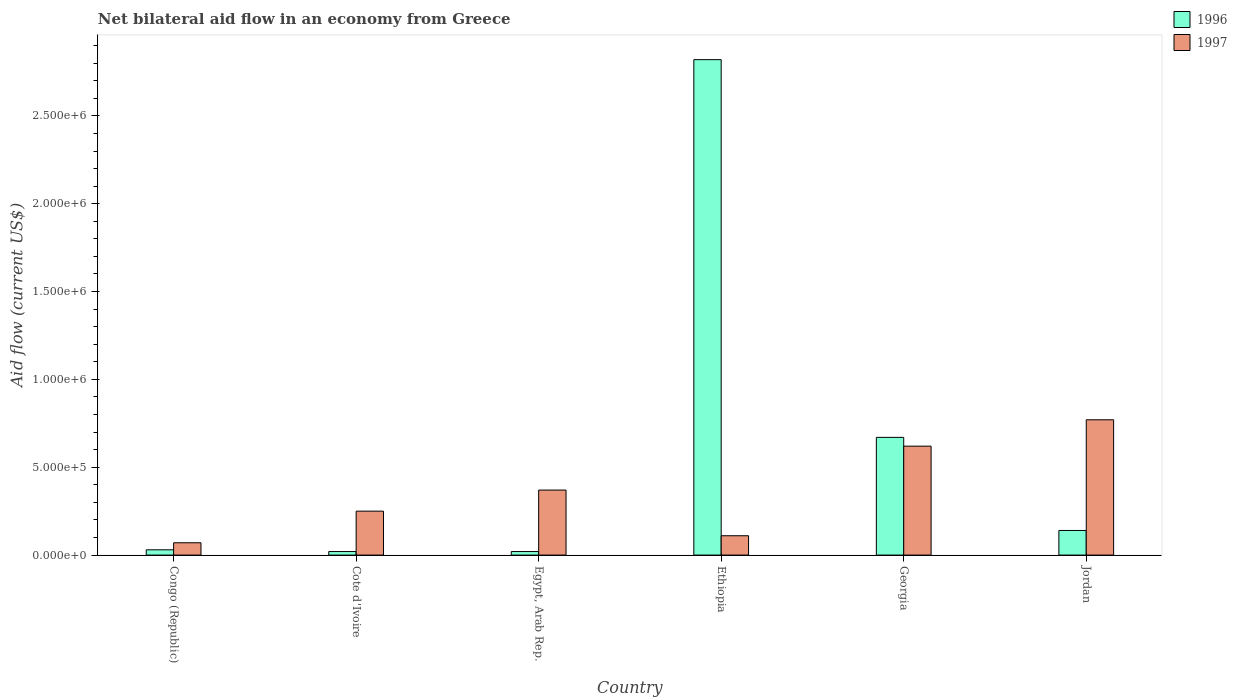How many groups of bars are there?
Your response must be concise. 6. Are the number of bars per tick equal to the number of legend labels?
Your answer should be very brief. Yes. Are the number of bars on each tick of the X-axis equal?
Offer a terse response. Yes. What is the label of the 2nd group of bars from the left?
Give a very brief answer. Cote d'Ivoire. In how many cases, is the number of bars for a given country not equal to the number of legend labels?
Make the answer very short. 0. Across all countries, what is the maximum net bilateral aid flow in 1997?
Your response must be concise. 7.70e+05. In which country was the net bilateral aid flow in 1996 maximum?
Keep it short and to the point. Ethiopia. In which country was the net bilateral aid flow in 1996 minimum?
Your response must be concise. Cote d'Ivoire. What is the total net bilateral aid flow in 1997 in the graph?
Your answer should be very brief. 2.19e+06. What is the difference between the net bilateral aid flow in 1996 in Congo (Republic) and that in Egypt, Arab Rep.?
Offer a terse response. 10000. What is the difference between the net bilateral aid flow in 1996 in Jordan and the net bilateral aid flow in 1997 in Ethiopia?
Keep it short and to the point. 3.00e+04. What is the average net bilateral aid flow in 1996 per country?
Your answer should be compact. 6.17e+05. What is the difference between the net bilateral aid flow of/in 1996 and net bilateral aid flow of/in 1997 in Cote d'Ivoire?
Your answer should be very brief. -2.30e+05. What is the ratio of the net bilateral aid flow in 1997 in Congo (Republic) to that in Egypt, Arab Rep.?
Keep it short and to the point. 0.19. Is the difference between the net bilateral aid flow in 1996 in Cote d'Ivoire and Jordan greater than the difference between the net bilateral aid flow in 1997 in Cote d'Ivoire and Jordan?
Keep it short and to the point. Yes. What is the difference between the highest and the lowest net bilateral aid flow in 1996?
Provide a short and direct response. 2.80e+06. In how many countries, is the net bilateral aid flow in 1996 greater than the average net bilateral aid flow in 1996 taken over all countries?
Provide a succinct answer. 2. Is the sum of the net bilateral aid flow in 1997 in Congo (Republic) and Ethiopia greater than the maximum net bilateral aid flow in 1996 across all countries?
Your answer should be very brief. No. What does the 2nd bar from the left in Cote d'Ivoire represents?
Make the answer very short. 1997. What does the 2nd bar from the right in Egypt, Arab Rep. represents?
Provide a short and direct response. 1996. How many bars are there?
Offer a terse response. 12. Are all the bars in the graph horizontal?
Provide a succinct answer. No. How many countries are there in the graph?
Make the answer very short. 6. Does the graph contain any zero values?
Give a very brief answer. No. How many legend labels are there?
Your answer should be very brief. 2. How are the legend labels stacked?
Ensure brevity in your answer.  Vertical. What is the title of the graph?
Give a very brief answer. Net bilateral aid flow in an economy from Greece. What is the label or title of the X-axis?
Ensure brevity in your answer.  Country. What is the label or title of the Y-axis?
Provide a succinct answer. Aid flow (current US$). What is the Aid flow (current US$) of 1996 in Congo (Republic)?
Provide a short and direct response. 3.00e+04. What is the Aid flow (current US$) in 1997 in Congo (Republic)?
Offer a terse response. 7.00e+04. What is the Aid flow (current US$) of 1996 in Cote d'Ivoire?
Your response must be concise. 2.00e+04. What is the Aid flow (current US$) in 1997 in Egypt, Arab Rep.?
Keep it short and to the point. 3.70e+05. What is the Aid flow (current US$) in 1996 in Ethiopia?
Offer a terse response. 2.82e+06. What is the Aid flow (current US$) of 1997 in Ethiopia?
Your response must be concise. 1.10e+05. What is the Aid flow (current US$) in 1996 in Georgia?
Offer a terse response. 6.70e+05. What is the Aid flow (current US$) in 1997 in Georgia?
Give a very brief answer. 6.20e+05. What is the Aid flow (current US$) of 1996 in Jordan?
Provide a succinct answer. 1.40e+05. What is the Aid flow (current US$) of 1997 in Jordan?
Your response must be concise. 7.70e+05. Across all countries, what is the maximum Aid flow (current US$) in 1996?
Keep it short and to the point. 2.82e+06. Across all countries, what is the maximum Aid flow (current US$) in 1997?
Provide a succinct answer. 7.70e+05. Across all countries, what is the minimum Aid flow (current US$) in 1996?
Ensure brevity in your answer.  2.00e+04. Across all countries, what is the minimum Aid flow (current US$) in 1997?
Provide a succinct answer. 7.00e+04. What is the total Aid flow (current US$) of 1996 in the graph?
Offer a very short reply. 3.70e+06. What is the total Aid flow (current US$) of 1997 in the graph?
Your answer should be very brief. 2.19e+06. What is the difference between the Aid flow (current US$) of 1997 in Congo (Republic) and that in Cote d'Ivoire?
Your answer should be very brief. -1.80e+05. What is the difference between the Aid flow (current US$) in 1996 in Congo (Republic) and that in Egypt, Arab Rep.?
Provide a short and direct response. 10000. What is the difference between the Aid flow (current US$) of 1997 in Congo (Republic) and that in Egypt, Arab Rep.?
Give a very brief answer. -3.00e+05. What is the difference between the Aid flow (current US$) of 1996 in Congo (Republic) and that in Ethiopia?
Keep it short and to the point. -2.79e+06. What is the difference between the Aid flow (current US$) in 1997 in Congo (Republic) and that in Ethiopia?
Provide a succinct answer. -4.00e+04. What is the difference between the Aid flow (current US$) of 1996 in Congo (Republic) and that in Georgia?
Ensure brevity in your answer.  -6.40e+05. What is the difference between the Aid flow (current US$) in 1997 in Congo (Republic) and that in Georgia?
Provide a short and direct response. -5.50e+05. What is the difference between the Aid flow (current US$) in 1996 in Congo (Republic) and that in Jordan?
Offer a very short reply. -1.10e+05. What is the difference between the Aid flow (current US$) in 1997 in Congo (Republic) and that in Jordan?
Offer a terse response. -7.00e+05. What is the difference between the Aid flow (current US$) of 1997 in Cote d'Ivoire and that in Egypt, Arab Rep.?
Provide a succinct answer. -1.20e+05. What is the difference between the Aid flow (current US$) in 1996 in Cote d'Ivoire and that in Ethiopia?
Your response must be concise. -2.80e+06. What is the difference between the Aid flow (current US$) in 1997 in Cote d'Ivoire and that in Ethiopia?
Offer a very short reply. 1.40e+05. What is the difference between the Aid flow (current US$) in 1996 in Cote d'Ivoire and that in Georgia?
Give a very brief answer. -6.50e+05. What is the difference between the Aid flow (current US$) in 1997 in Cote d'Ivoire and that in Georgia?
Your answer should be compact. -3.70e+05. What is the difference between the Aid flow (current US$) of 1997 in Cote d'Ivoire and that in Jordan?
Provide a short and direct response. -5.20e+05. What is the difference between the Aid flow (current US$) in 1996 in Egypt, Arab Rep. and that in Ethiopia?
Offer a very short reply. -2.80e+06. What is the difference between the Aid flow (current US$) in 1997 in Egypt, Arab Rep. and that in Ethiopia?
Give a very brief answer. 2.60e+05. What is the difference between the Aid flow (current US$) in 1996 in Egypt, Arab Rep. and that in Georgia?
Make the answer very short. -6.50e+05. What is the difference between the Aid flow (current US$) of 1997 in Egypt, Arab Rep. and that in Jordan?
Give a very brief answer. -4.00e+05. What is the difference between the Aid flow (current US$) in 1996 in Ethiopia and that in Georgia?
Your response must be concise. 2.15e+06. What is the difference between the Aid flow (current US$) of 1997 in Ethiopia and that in Georgia?
Make the answer very short. -5.10e+05. What is the difference between the Aid flow (current US$) in 1996 in Ethiopia and that in Jordan?
Your answer should be very brief. 2.68e+06. What is the difference between the Aid flow (current US$) of 1997 in Ethiopia and that in Jordan?
Your response must be concise. -6.60e+05. What is the difference between the Aid flow (current US$) of 1996 in Georgia and that in Jordan?
Your answer should be very brief. 5.30e+05. What is the difference between the Aid flow (current US$) of 1997 in Georgia and that in Jordan?
Give a very brief answer. -1.50e+05. What is the difference between the Aid flow (current US$) of 1996 in Congo (Republic) and the Aid flow (current US$) of 1997 in Egypt, Arab Rep.?
Your answer should be compact. -3.40e+05. What is the difference between the Aid flow (current US$) in 1996 in Congo (Republic) and the Aid flow (current US$) in 1997 in Georgia?
Give a very brief answer. -5.90e+05. What is the difference between the Aid flow (current US$) in 1996 in Congo (Republic) and the Aid flow (current US$) in 1997 in Jordan?
Provide a succinct answer. -7.40e+05. What is the difference between the Aid flow (current US$) of 1996 in Cote d'Ivoire and the Aid flow (current US$) of 1997 in Egypt, Arab Rep.?
Make the answer very short. -3.50e+05. What is the difference between the Aid flow (current US$) of 1996 in Cote d'Ivoire and the Aid flow (current US$) of 1997 in Georgia?
Your response must be concise. -6.00e+05. What is the difference between the Aid flow (current US$) in 1996 in Cote d'Ivoire and the Aid flow (current US$) in 1997 in Jordan?
Ensure brevity in your answer.  -7.50e+05. What is the difference between the Aid flow (current US$) in 1996 in Egypt, Arab Rep. and the Aid flow (current US$) in 1997 in Georgia?
Your answer should be compact. -6.00e+05. What is the difference between the Aid flow (current US$) in 1996 in Egypt, Arab Rep. and the Aid flow (current US$) in 1997 in Jordan?
Provide a succinct answer. -7.50e+05. What is the difference between the Aid flow (current US$) of 1996 in Ethiopia and the Aid flow (current US$) of 1997 in Georgia?
Offer a terse response. 2.20e+06. What is the difference between the Aid flow (current US$) in 1996 in Ethiopia and the Aid flow (current US$) in 1997 in Jordan?
Give a very brief answer. 2.05e+06. What is the difference between the Aid flow (current US$) of 1996 in Georgia and the Aid flow (current US$) of 1997 in Jordan?
Make the answer very short. -1.00e+05. What is the average Aid flow (current US$) in 1996 per country?
Ensure brevity in your answer.  6.17e+05. What is the average Aid flow (current US$) in 1997 per country?
Keep it short and to the point. 3.65e+05. What is the difference between the Aid flow (current US$) of 1996 and Aid flow (current US$) of 1997 in Egypt, Arab Rep.?
Provide a succinct answer. -3.50e+05. What is the difference between the Aid flow (current US$) of 1996 and Aid flow (current US$) of 1997 in Ethiopia?
Provide a short and direct response. 2.71e+06. What is the difference between the Aid flow (current US$) of 1996 and Aid flow (current US$) of 1997 in Georgia?
Your answer should be compact. 5.00e+04. What is the difference between the Aid flow (current US$) in 1996 and Aid flow (current US$) in 1997 in Jordan?
Offer a terse response. -6.30e+05. What is the ratio of the Aid flow (current US$) of 1997 in Congo (Republic) to that in Cote d'Ivoire?
Make the answer very short. 0.28. What is the ratio of the Aid flow (current US$) of 1996 in Congo (Republic) to that in Egypt, Arab Rep.?
Your answer should be very brief. 1.5. What is the ratio of the Aid flow (current US$) in 1997 in Congo (Republic) to that in Egypt, Arab Rep.?
Your answer should be very brief. 0.19. What is the ratio of the Aid flow (current US$) of 1996 in Congo (Republic) to that in Ethiopia?
Provide a succinct answer. 0.01. What is the ratio of the Aid flow (current US$) of 1997 in Congo (Republic) to that in Ethiopia?
Provide a succinct answer. 0.64. What is the ratio of the Aid flow (current US$) of 1996 in Congo (Republic) to that in Georgia?
Offer a very short reply. 0.04. What is the ratio of the Aid flow (current US$) of 1997 in Congo (Republic) to that in Georgia?
Provide a short and direct response. 0.11. What is the ratio of the Aid flow (current US$) of 1996 in Congo (Republic) to that in Jordan?
Offer a terse response. 0.21. What is the ratio of the Aid flow (current US$) of 1997 in Congo (Republic) to that in Jordan?
Make the answer very short. 0.09. What is the ratio of the Aid flow (current US$) of 1997 in Cote d'Ivoire to that in Egypt, Arab Rep.?
Provide a short and direct response. 0.68. What is the ratio of the Aid flow (current US$) in 1996 in Cote d'Ivoire to that in Ethiopia?
Provide a short and direct response. 0.01. What is the ratio of the Aid flow (current US$) of 1997 in Cote d'Ivoire to that in Ethiopia?
Give a very brief answer. 2.27. What is the ratio of the Aid flow (current US$) in 1996 in Cote d'Ivoire to that in Georgia?
Keep it short and to the point. 0.03. What is the ratio of the Aid flow (current US$) in 1997 in Cote d'Ivoire to that in Georgia?
Keep it short and to the point. 0.4. What is the ratio of the Aid flow (current US$) in 1996 in Cote d'Ivoire to that in Jordan?
Provide a succinct answer. 0.14. What is the ratio of the Aid flow (current US$) in 1997 in Cote d'Ivoire to that in Jordan?
Offer a very short reply. 0.32. What is the ratio of the Aid flow (current US$) in 1996 in Egypt, Arab Rep. to that in Ethiopia?
Give a very brief answer. 0.01. What is the ratio of the Aid flow (current US$) in 1997 in Egypt, Arab Rep. to that in Ethiopia?
Offer a terse response. 3.36. What is the ratio of the Aid flow (current US$) in 1996 in Egypt, Arab Rep. to that in Georgia?
Your answer should be compact. 0.03. What is the ratio of the Aid flow (current US$) in 1997 in Egypt, Arab Rep. to that in Georgia?
Provide a short and direct response. 0.6. What is the ratio of the Aid flow (current US$) of 1996 in Egypt, Arab Rep. to that in Jordan?
Your answer should be compact. 0.14. What is the ratio of the Aid flow (current US$) of 1997 in Egypt, Arab Rep. to that in Jordan?
Keep it short and to the point. 0.48. What is the ratio of the Aid flow (current US$) in 1996 in Ethiopia to that in Georgia?
Give a very brief answer. 4.21. What is the ratio of the Aid flow (current US$) of 1997 in Ethiopia to that in Georgia?
Offer a very short reply. 0.18. What is the ratio of the Aid flow (current US$) in 1996 in Ethiopia to that in Jordan?
Make the answer very short. 20.14. What is the ratio of the Aid flow (current US$) in 1997 in Ethiopia to that in Jordan?
Your response must be concise. 0.14. What is the ratio of the Aid flow (current US$) of 1996 in Georgia to that in Jordan?
Ensure brevity in your answer.  4.79. What is the ratio of the Aid flow (current US$) in 1997 in Georgia to that in Jordan?
Your answer should be compact. 0.81. What is the difference between the highest and the second highest Aid flow (current US$) of 1996?
Make the answer very short. 2.15e+06. What is the difference between the highest and the lowest Aid flow (current US$) in 1996?
Your response must be concise. 2.80e+06. What is the difference between the highest and the lowest Aid flow (current US$) of 1997?
Keep it short and to the point. 7.00e+05. 